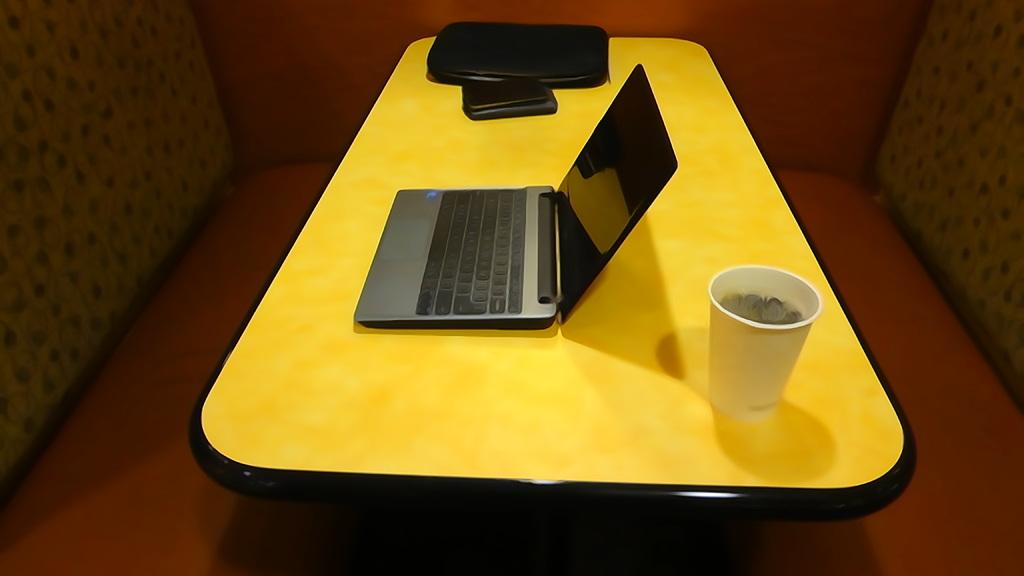What piece of furniture is present in the image? There is a table in the image. What can be seen on top of the table? There is a glass, a laptop, a phone, and a laptop cover on the table. What type of device is on the table for communication purposes? There is a phone on the table for communication purposes. What might be used to protect the laptop when not in use? There is a laptop cover on the table, which might be used to protect the laptop. What scent is emanating from the glass in the image? There is no mention of a scent in the image, and the glass does not have any fragrance associated with it. 